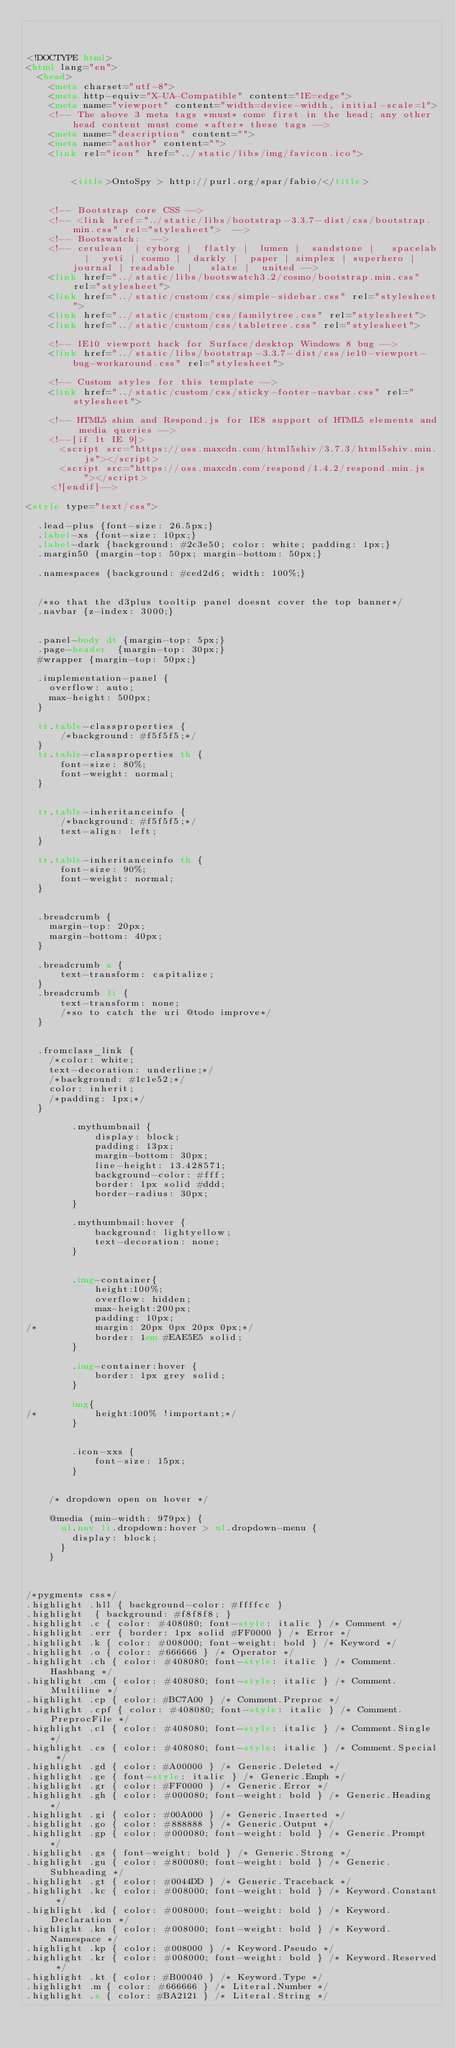Convert code to text. <code><loc_0><loc_0><loc_500><loc_500><_HTML_>


<!DOCTYPE html>
<html lang="en">
  <head>
    <meta charset="utf-8">
    <meta http-equiv="X-UA-Compatible" content="IE=edge">
    <meta name="viewport" content="width=device-width, initial-scale=1">
    <!-- The above 3 meta tags *must* come first in the head; any other head content must come *after* these tags -->
    <meta name="description" content="">
    <meta name="author" content="">
    <link rel="icon" href="../static/libs/img/favicon.ico">

	
		<title>OntoSpy > http://purl.org/spar/fabio/</title>
	

    <!-- Bootstrap core CSS -->
    <!-- <link href="../static/libs/bootstrap-3.3.7-dist/css/bootstrap.min.css" rel="stylesheet">  -->
    <!-- Bootswatch:  -->
    <!-- cerulean  | cyborg |  flatly |  lumen |  sandstone |   spacelab  |  yeti | cosmo |  darkly |  paper | simplex | superhero |  journal | readable  |   slate |  united -->
    <link href="../static/libs/bootswatch3.2/cosmo/bootstrap.min.css" rel="stylesheet">
    <link href="../static/custom/css/simple-sidebar.css" rel="stylesheet">
    <link href="../static/custom/css/familytree.css" rel="stylesheet">
    <link href="../static/custom/css/tabletree.css" rel="stylesheet">

    <!-- IE10 viewport hack for Surface/desktop Windows 8 bug -->
    <link href="../static/libs/bootstrap-3.3.7-dist/css/ie10-viewport-bug-workaround.css" rel="stylesheet">

    <!-- Custom styles for this template -->
    <link href="../static/custom/css/sticky-footer-navbar.css" rel="stylesheet">

    <!-- HTML5 shim and Respond.js for IE8 support of HTML5 elements and media queries -->
    <!--[if lt IE 9]>
      <script src="https://oss.maxcdn.com/html5shiv/3.7.3/html5shiv.min.js"></script>
      <script src="https://oss.maxcdn.com/respond/1.4.2/respond.min.js"></script>
    <![endif]-->

<style type="text/css">

  .lead-plus {font-size: 26.5px;}
  .label-xs {font-size: 10px;}
  .label-dark {background: #2c3e50; color: white; padding: 1px;}
  .margin50 {margin-top: 50px; margin-bottom: 50px;}

  .namespaces {background: #ced2d6; width: 100%;}


  /*so that the d3plus tooltip panel doesnt cover the top banner*/
  .navbar {z-index: 3000;}


  .panel-body dt {margin-top: 5px;}
  .page-header  {margin-top: 30px;}
  #wrapper {margin-top: 50px;}

  .implementation-panel {
    overflow: auto;
    max-height: 500px;
  }

  tr.table-classproperties {
      /*background: #f5f5f5;*/
  }
  tr.table-classproperties th {
      font-size: 80%;
      font-weight: normal;
  }


  tr.table-inheritanceinfo {
      /*background: #f5f5f5;*/
      text-align: left;
  }

  tr.table-inheritanceinfo th {
      font-size: 90%;
      font-weight: normal;
  }


  .breadcrumb {
    margin-top: 20px;
    margin-bottom: 40px;
  }

  .breadcrumb a {
      text-transform: capitalize;
  }
  .breadcrumb li {
      text-transform: none;
      /*so to catch the uri @todo improve*/
  }


  .fromclass_link {
    /*color: white;
    text-decoration: underline;*/
    /*background: #1c1e52;*/
    color: inherit;
    /*padding: 1px;*/
  }

		.mythumbnail {
			display: block;
			padding: 13px;
			margin-bottom: 30px;
			line-height: 13.428571;
			background-color: #fff;
			border: 1px solid #ddd;
			border-radius: 30px;
		}

		.mythumbnail:hover {
			background: lightyellow;
			text-decoration: none;
		}


		.img-container{
		    height:100%;
			overflow: hidden;
		    max-height:200px;
			padding: 10px;
/*			margin: 20px 0px 20px 0px;*/
			border: 1em #EAE5E5 solid;
		}

		.img-container:hover {
			border: 1px grey solid;
		}

		img{
/*		    height:100% !important;*/
		}


		.icon-xxs {
			font-size: 15px;
		}


    /* dropdown open on hover */

    @media (min-width: 979px) {
      ul.nav li.dropdown:hover > ul.dropdown-menu {
        display: block;
      }
    }



/*pygments css*/
.highlight .hll { background-color: #ffffcc }
.highlight  { background: #f8f8f8; }
.highlight .c { color: #408080; font-style: italic } /* Comment */
.highlight .err { border: 1px solid #FF0000 } /* Error */
.highlight .k { color: #008000; font-weight: bold } /* Keyword */
.highlight .o { color: #666666 } /* Operator */
.highlight .ch { color: #408080; font-style: italic } /* Comment.Hashbang */
.highlight .cm { color: #408080; font-style: italic } /* Comment.Multiline */
.highlight .cp { color: #BC7A00 } /* Comment.Preproc */
.highlight .cpf { color: #408080; font-style: italic } /* Comment.PreprocFile */
.highlight .c1 { color: #408080; font-style: italic } /* Comment.Single */
.highlight .cs { color: #408080; font-style: italic } /* Comment.Special */
.highlight .gd { color: #A00000 } /* Generic.Deleted */
.highlight .ge { font-style: italic } /* Generic.Emph */
.highlight .gr { color: #FF0000 } /* Generic.Error */
.highlight .gh { color: #000080; font-weight: bold } /* Generic.Heading */
.highlight .gi { color: #00A000 } /* Generic.Inserted */
.highlight .go { color: #888888 } /* Generic.Output */
.highlight .gp { color: #000080; font-weight: bold } /* Generic.Prompt */
.highlight .gs { font-weight: bold } /* Generic.Strong */
.highlight .gu { color: #800080; font-weight: bold } /* Generic.Subheading */
.highlight .gt { color: #0044DD } /* Generic.Traceback */
.highlight .kc { color: #008000; font-weight: bold } /* Keyword.Constant */
.highlight .kd { color: #008000; font-weight: bold } /* Keyword.Declaration */
.highlight .kn { color: #008000; font-weight: bold } /* Keyword.Namespace */
.highlight .kp { color: #008000 } /* Keyword.Pseudo */
.highlight .kr { color: #008000; font-weight: bold } /* Keyword.Reserved */
.highlight .kt { color: #B00040 } /* Keyword.Type */
.highlight .m { color: #666666 } /* Literal.Number */
.highlight .s { color: #BA2121 } /* Literal.String */</code> 